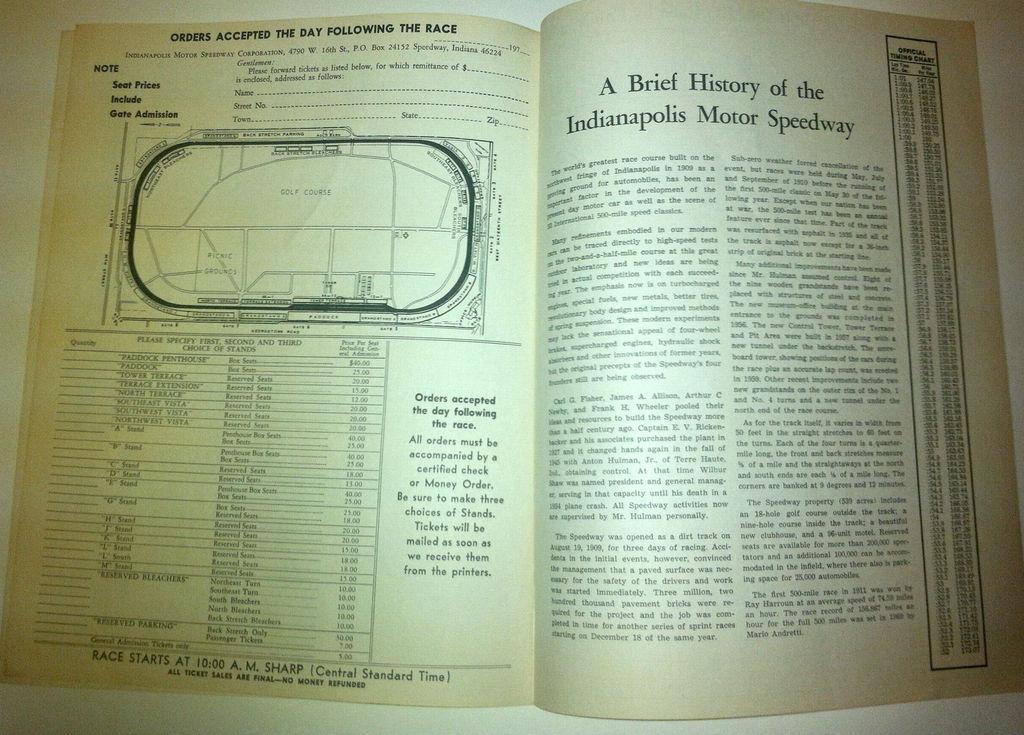What time did the race start?
Provide a short and direct response. 10:00 am. 